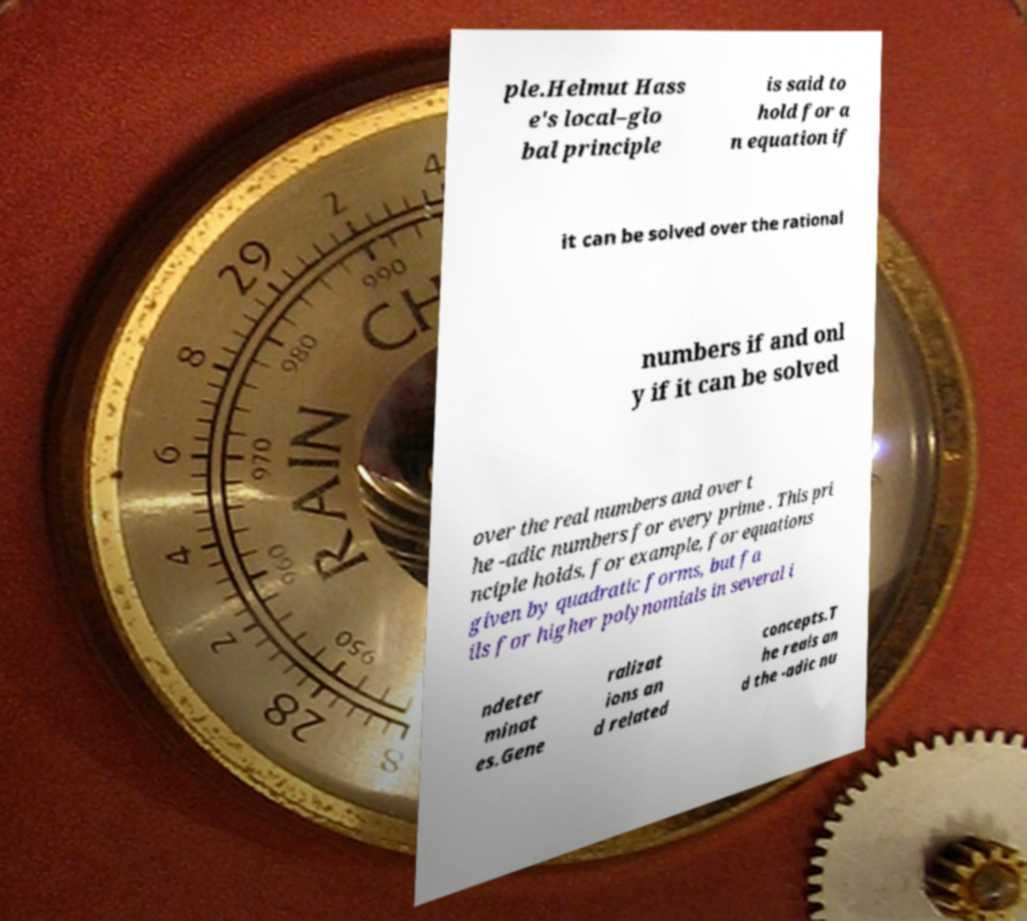I need the written content from this picture converted into text. Can you do that? ple.Helmut Hass e's local–glo bal principle is said to hold for a n equation if it can be solved over the rational numbers if and onl y if it can be solved over the real numbers and over t he -adic numbers for every prime . This pri nciple holds, for example, for equations given by quadratic forms, but fa ils for higher polynomials in several i ndeter minat es.Gene ralizat ions an d related concepts.T he reals an d the -adic nu 